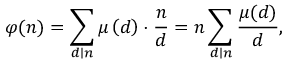<formula> <loc_0><loc_0><loc_500><loc_500>\varphi ( n ) = \sum _ { d | n } \mu \left ( d \right ) \cdot { \frac { n } { d } } = n \sum _ { d | n } { \frac { \mu ( d ) } { d } } ,</formula> 